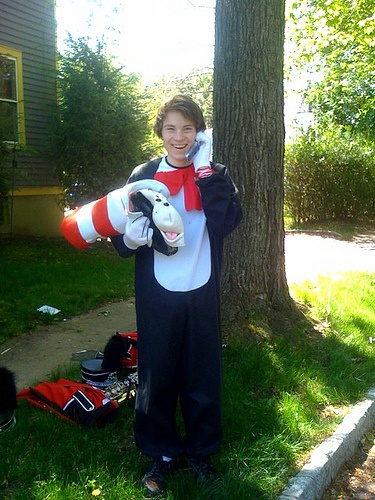Describe the objects in this image and their specific colors. I can see people in gray, black, and lightblue tones and cell phone in gray and blue tones in this image. 